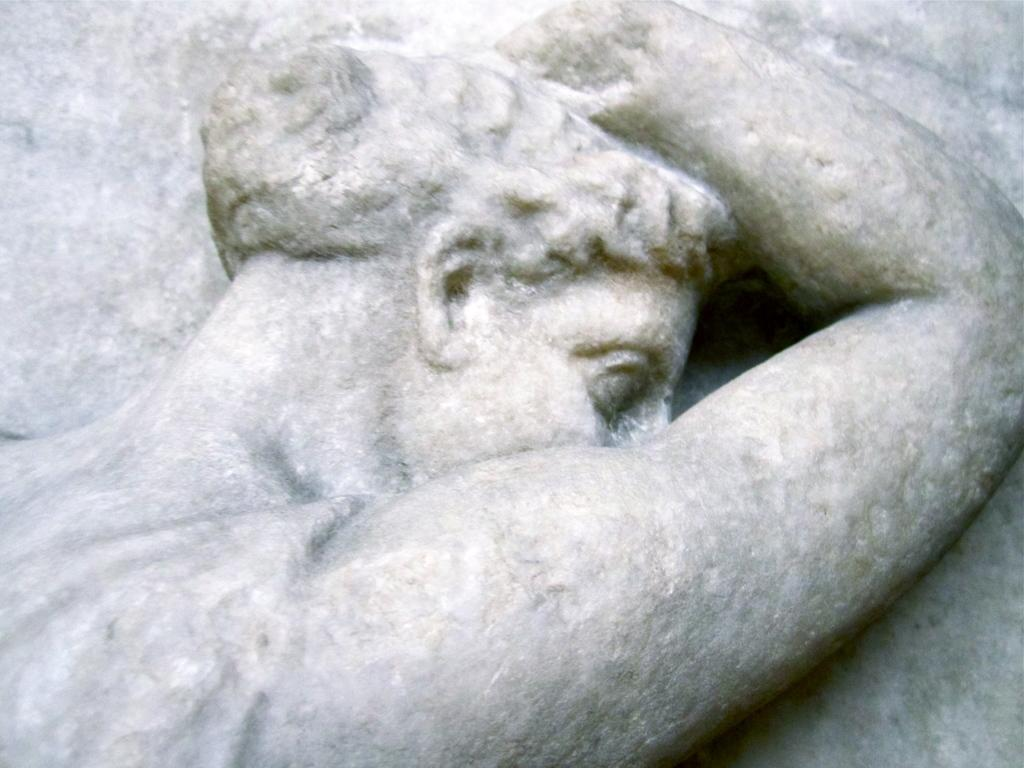What type of statue is depicted in the image? There is a human statue in the image. What material is the statue made of? The statue is made of rock. What part of the statue can be seen in the image? The image shows the upper part of the statue. How many cattle are standing on the shelf behind the statue in the image? There are no cattle or shelves present in the image; it features a human statue made of rock. 